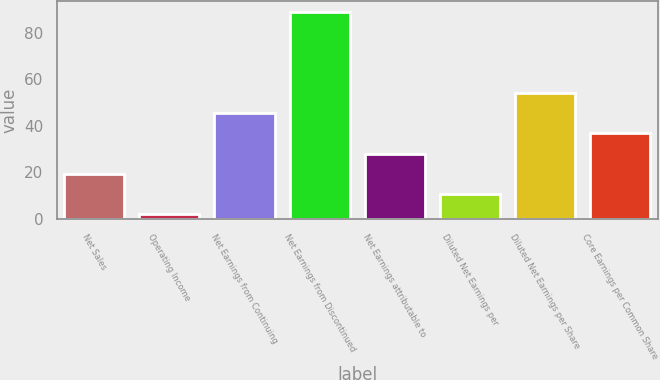Convert chart. <chart><loc_0><loc_0><loc_500><loc_500><bar_chart><fcel>Net Sales<fcel>Operating Income<fcel>Net Earnings from Continuing<fcel>Net Earnings from Discontinued<fcel>Net Earnings attributable to<fcel>Diluted Net Earnings per<fcel>Diluted Net Earnings per Share<fcel>Core Earnings per Common Share<nl><fcel>19.4<fcel>2<fcel>45.5<fcel>89<fcel>28.1<fcel>10.7<fcel>54.2<fcel>36.8<nl></chart> 